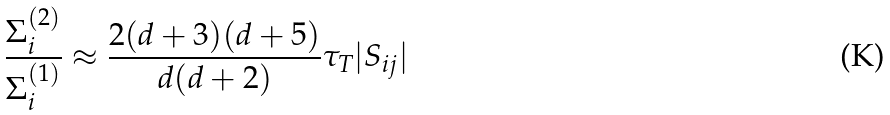<formula> <loc_0><loc_0><loc_500><loc_500>\frac { \Sigma _ { i } ^ { ( 2 ) } } { \Sigma _ { i } ^ { ( 1 ) } } \approx \frac { 2 ( d + 3 ) ( d + 5 ) } { d ( d + 2 ) } \tau _ { T } | S _ { i j } |</formula> 